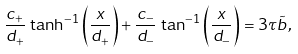<formula> <loc_0><loc_0><loc_500><loc_500>\frac { c _ { + } } { d _ { + } } \, \tanh ^ { - 1 } \left ( \frac { x } { d _ { + } } \right ) + \frac { c _ { - } } { d _ { - } } \, \tan ^ { - 1 } \left ( \frac { x } { d _ { - } } \right ) = 3 \tau \tilde { b } \, ,</formula> 